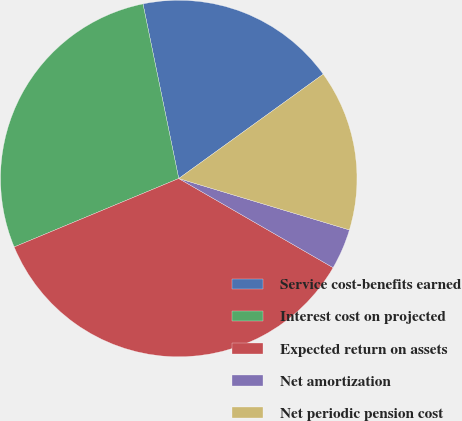Convert chart. <chart><loc_0><loc_0><loc_500><loc_500><pie_chart><fcel>Service cost-benefits earned<fcel>Interest cost on projected<fcel>Expected return on assets<fcel>Net amortization<fcel>Net periodic pension cost<nl><fcel>18.26%<fcel>28.06%<fcel>35.39%<fcel>3.68%<fcel>14.61%<nl></chart> 